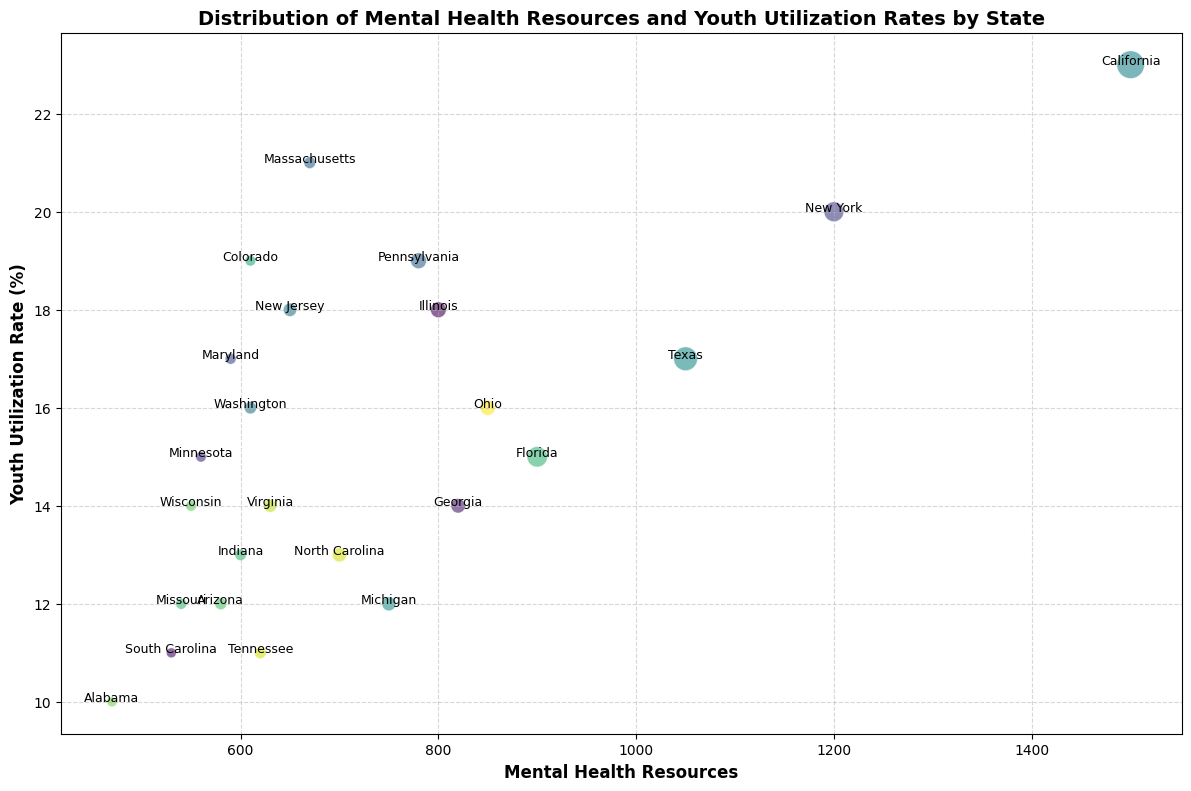Which state has the highest youth utilization rate? By comparing the positions of all the states on the Y-axis (Youth Utilization Rate), we see that California has the highest rate at 23%.
Answer: California How does New York's mental health resources compare to Illinois? New York has 1200 mental health resources while Illinois has 800. Thus, New York has more mental health resources.
Answer: New York Which state has a larger bubble, California or Texas, and what does that mean? California's bubble is larger than Texas's, indicating that California has a higher population.
Answer: California What is the range in youth utilization rates across all states? By looking at the minimum and maximum positions on the Y-axis, youth utilization rates range from 10% (Alabama) to 23% (California).
Answer: 10-23% Is there a state with more mental health resources but a lower youth utilization rate than New York? Yes, Texas has 1050 mental health resources but a lower youth utilization rate of 17%, compared to New York's 20%.
Answer: Texas What color is the bubble for Florida, and does that indicate anything specific? The bubbles are randomly colored, so Florida’s specific color does not indicate any particular attribute.
Answer: Random color Which state(s) appear close to the center of the plot, and what does that signify? Ohio and Washington are near the center, indicating they have median values for both mental health resources and youth utilization rates.
Answer: Ohio and Washington Which states have the smallest and largest bubbles? The smallest bubbles correspond to states like South Carolina and Alabama, indicating small populations. The largest bubble is for California, indicating the largest population.
Answer: California, Alabama/South Carolina Between Ohio and Virginia, which state has a higher youth utilization rate? By comparing their positions on the Y-axis, Ohio has a youth utilization rate of 16%, while Virginia has 14%. Thus, Ohio has a higher rate.
Answer: Ohio How many states have a youth utilization rate of 16% or higher? By scanning the Y-axis, there are 9 states with a youth utilization rate of 16% or higher: California, New York, Illinois, Pennsylvania, Ohio, New Jersey, Maryland, Washington, and Colorado.
Answer: 9 